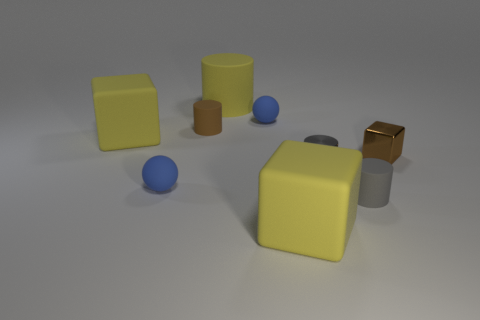Subtract all small brown metal blocks. How many blocks are left? 2 Subtract all purple cubes. How many gray cylinders are left? 2 Subtract all cylinders. How many objects are left? 5 Add 1 small blue balls. How many objects exist? 10 Subtract all brown blocks. How many blocks are left? 2 Subtract all green shiny cylinders. Subtract all brown shiny blocks. How many objects are left? 8 Add 2 tiny matte things. How many tiny matte things are left? 6 Add 7 brown rubber things. How many brown rubber things exist? 8 Subtract 0 cyan cubes. How many objects are left? 9 Subtract all brown cubes. Subtract all brown cylinders. How many cubes are left? 2 